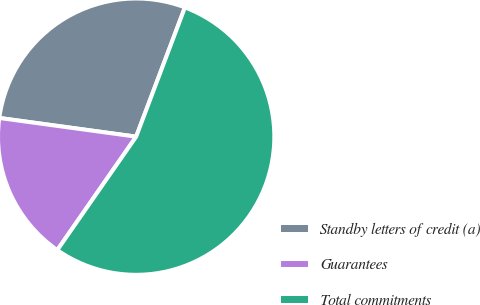<chart> <loc_0><loc_0><loc_500><loc_500><pie_chart><fcel>Standby letters of credit (a)<fcel>Guarantees<fcel>Total commitments<nl><fcel>28.58%<fcel>17.49%<fcel>53.93%<nl></chart> 